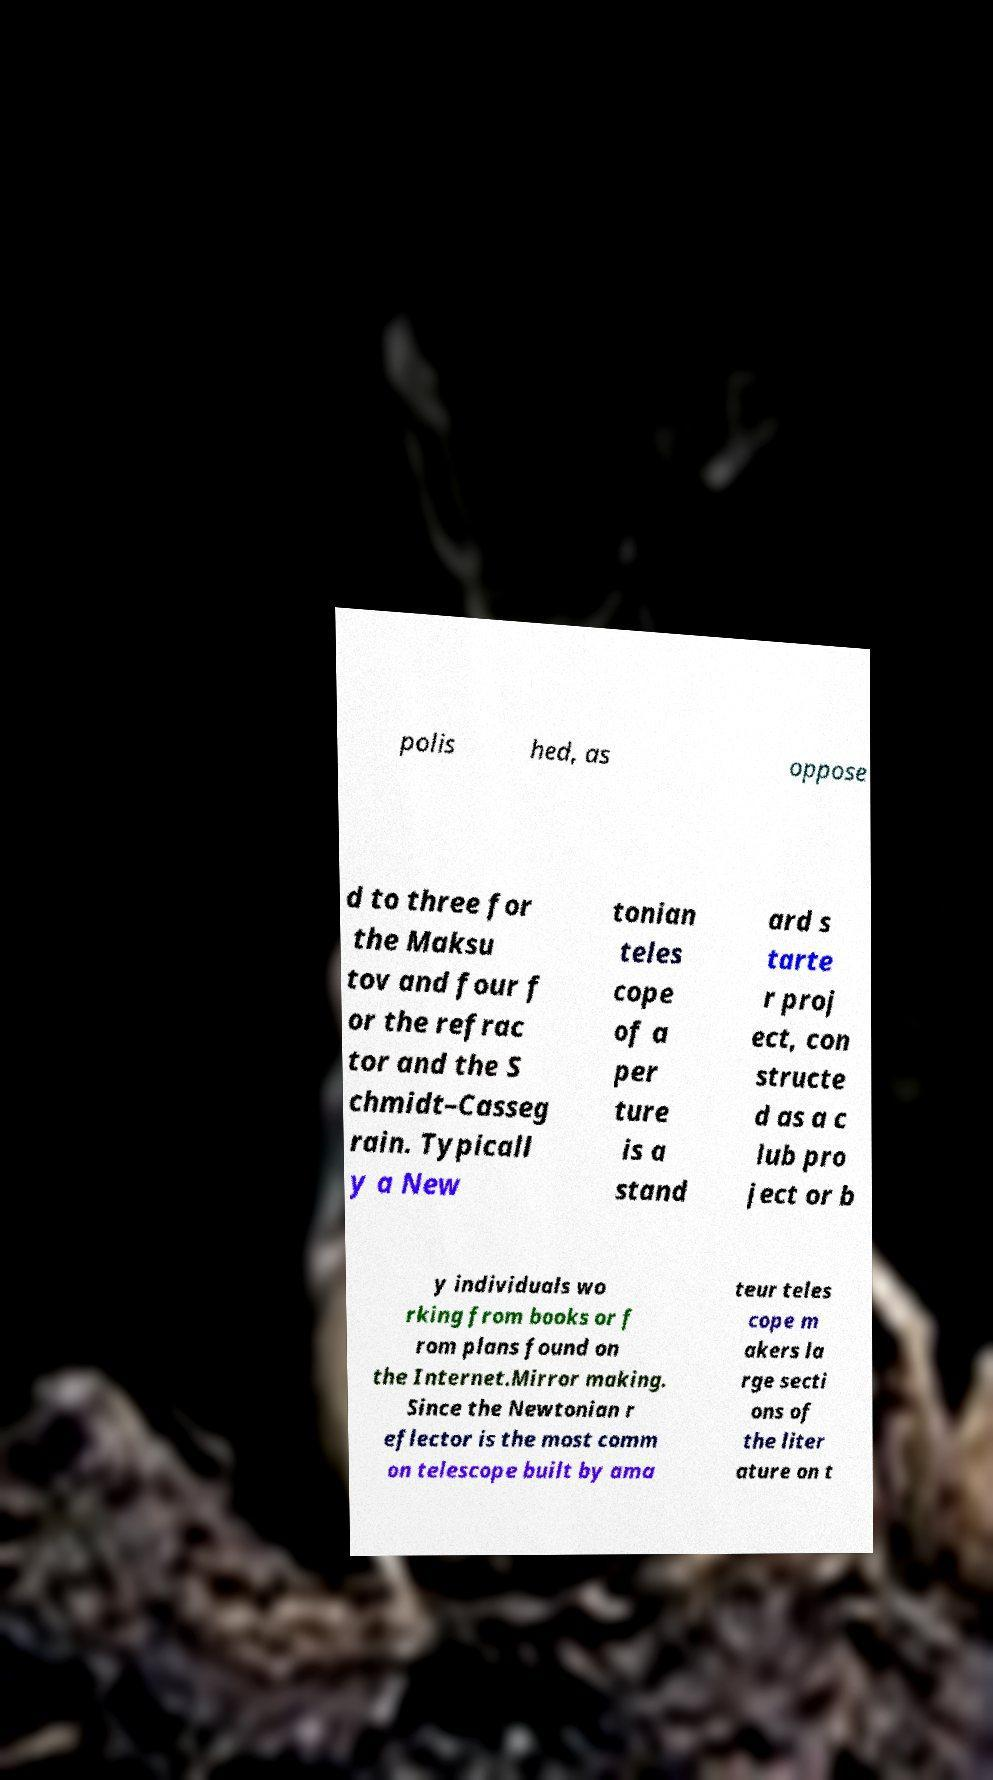Please read and relay the text visible in this image. What does it say? polis hed, as oppose d to three for the Maksu tov and four f or the refrac tor and the S chmidt–Casseg rain. Typicall y a New tonian teles cope of a per ture is a stand ard s tarte r proj ect, con structe d as a c lub pro ject or b y individuals wo rking from books or f rom plans found on the Internet.Mirror making. Since the Newtonian r eflector is the most comm on telescope built by ama teur teles cope m akers la rge secti ons of the liter ature on t 